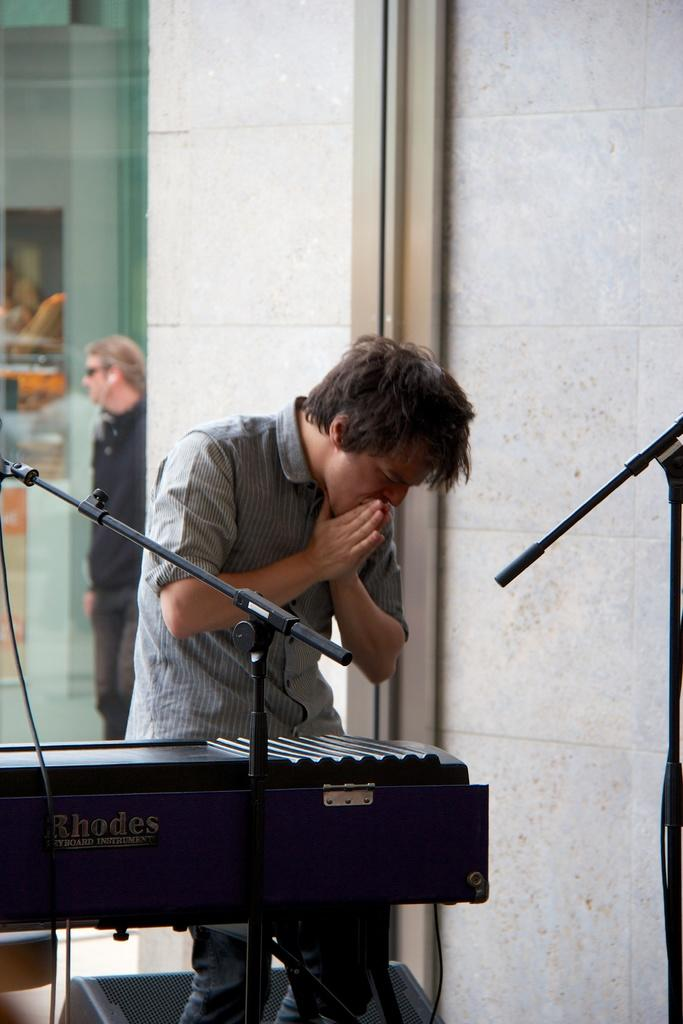What is the main subject of the image? There is a man standing in the image. What else can be seen in the image besides the man? There is a musical instrument in the image. Can you describe the background of the image? There is a glass window at the back side of the image. What type of tin can be seen in the image? There is no tin present in the image. How many cans are visible in the image? There are no cans visible in the image. 